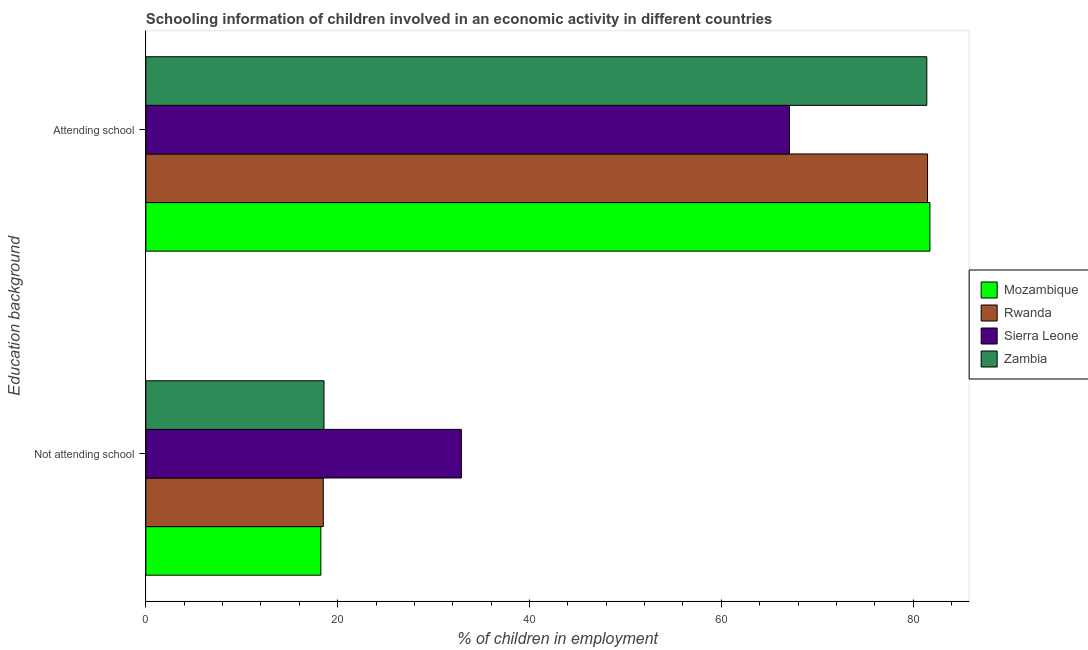Are the number of bars per tick equal to the number of legend labels?
Ensure brevity in your answer.  Yes. How many bars are there on the 2nd tick from the top?
Your answer should be very brief. 4. What is the label of the 1st group of bars from the top?
Keep it short and to the point. Attending school. What is the percentage of employed children who are attending school in Mozambique?
Provide a succinct answer. 81.75. Across all countries, what is the maximum percentage of employed children who are attending school?
Offer a very short reply. 81.75. Across all countries, what is the minimum percentage of employed children who are attending school?
Provide a succinct answer. 67.1. In which country was the percentage of employed children who are attending school maximum?
Provide a succinct answer. Mozambique. In which country was the percentage of employed children who are attending school minimum?
Ensure brevity in your answer.  Sierra Leone. What is the total percentage of employed children who are attending school in the graph?
Make the answer very short. 311.78. What is the difference between the percentage of employed children who are not attending school in Rwanda and that in Sierra Leone?
Your answer should be very brief. -14.4. What is the difference between the percentage of employed children who are attending school in Mozambique and the percentage of employed children who are not attending school in Rwanda?
Offer a very short reply. 63.25. What is the average percentage of employed children who are not attending school per country?
Keep it short and to the point. 22.06. What is the difference between the percentage of employed children who are not attending school and percentage of employed children who are attending school in Rwanda?
Provide a succinct answer. -63. In how many countries, is the percentage of employed children who are not attending school greater than 48 %?
Offer a terse response. 0. What is the ratio of the percentage of employed children who are not attending school in Sierra Leone to that in Rwanda?
Offer a terse response. 1.78. Is the percentage of employed children who are not attending school in Zambia less than that in Rwanda?
Your answer should be very brief. No. In how many countries, is the percentage of employed children who are not attending school greater than the average percentage of employed children who are not attending school taken over all countries?
Ensure brevity in your answer.  1. What does the 2nd bar from the top in Not attending school represents?
Offer a terse response. Sierra Leone. What does the 3rd bar from the bottom in Not attending school represents?
Provide a short and direct response. Sierra Leone. How many bars are there?
Keep it short and to the point. 8. How many countries are there in the graph?
Offer a terse response. 4. Does the graph contain any zero values?
Your response must be concise. No. Does the graph contain grids?
Offer a terse response. No. What is the title of the graph?
Provide a short and direct response. Schooling information of children involved in an economic activity in different countries. Does "Afghanistan" appear as one of the legend labels in the graph?
Keep it short and to the point. No. What is the label or title of the X-axis?
Your response must be concise. % of children in employment. What is the label or title of the Y-axis?
Provide a succinct answer. Education background. What is the % of children in employment in Mozambique in Not attending school?
Ensure brevity in your answer.  18.25. What is the % of children in employment of Sierra Leone in Not attending school?
Offer a terse response. 32.9. What is the % of children in employment of Zambia in Not attending school?
Ensure brevity in your answer.  18.58. What is the % of children in employment of Mozambique in Attending school?
Your response must be concise. 81.75. What is the % of children in employment of Rwanda in Attending school?
Provide a short and direct response. 81.5. What is the % of children in employment of Sierra Leone in Attending school?
Your response must be concise. 67.1. What is the % of children in employment of Zambia in Attending school?
Give a very brief answer. 81.42. Across all Education background, what is the maximum % of children in employment in Mozambique?
Provide a short and direct response. 81.75. Across all Education background, what is the maximum % of children in employment in Rwanda?
Offer a terse response. 81.5. Across all Education background, what is the maximum % of children in employment of Sierra Leone?
Your answer should be compact. 67.1. Across all Education background, what is the maximum % of children in employment of Zambia?
Give a very brief answer. 81.42. Across all Education background, what is the minimum % of children in employment in Mozambique?
Provide a succinct answer. 18.25. Across all Education background, what is the minimum % of children in employment of Sierra Leone?
Your response must be concise. 32.9. Across all Education background, what is the minimum % of children in employment in Zambia?
Your answer should be very brief. 18.58. What is the total % of children in employment of Mozambique in the graph?
Provide a short and direct response. 100. What is the total % of children in employment in Rwanda in the graph?
Offer a very short reply. 100. What is the total % of children in employment of Sierra Leone in the graph?
Provide a short and direct response. 100. What is the total % of children in employment in Zambia in the graph?
Make the answer very short. 100. What is the difference between the % of children in employment in Mozambique in Not attending school and that in Attending school?
Keep it short and to the point. -63.5. What is the difference between the % of children in employment in Rwanda in Not attending school and that in Attending school?
Ensure brevity in your answer.  -63. What is the difference between the % of children in employment of Sierra Leone in Not attending school and that in Attending school?
Keep it short and to the point. -34.2. What is the difference between the % of children in employment of Zambia in Not attending school and that in Attending school?
Your response must be concise. -62.85. What is the difference between the % of children in employment of Mozambique in Not attending school and the % of children in employment of Rwanda in Attending school?
Provide a short and direct response. -63.25. What is the difference between the % of children in employment in Mozambique in Not attending school and the % of children in employment in Sierra Leone in Attending school?
Keep it short and to the point. -48.85. What is the difference between the % of children in employment in Mozambique in Not attending school and the % of children in employment in Zambia in Attending school?
Keep it short and to the point. -63.18. What is the difference between the % of children in employment in Rwanda in Not attending school and the % of children in employment in Sierra Leone in Attending school?
Your answer should be compact. -48.6. What is the difference between the % of children in employment of Rwanda in Not attending school and the % of children in employment of Zambia in Attending school?
Make the answer very short. -62.92. What is the difference between the % of children in employment of Sierra Leone in Not attending school and the % of children in employment of Zambia in Attending school?
Offer a very short reply. -48.52. What is the average % of children in employment in Rwanda per Education background?
Provide a short and direct response. 50. What is the average % of children in employment in Sierra Leone per Education background?
Provide a short and direct response. 50. What is the average % of children in employment in Zambia per Education background?
Ensure brevity in your answer.  50. What is the difference between the % of children in employment in Mozambique and % of children in employment in Rwanda in Not attending school?
Offer a very short reply. -0.25. What is the difference between the % of children in employment of Mozambique and % of children in employment of Sierra Leone in Not attending school?
Provide a short and direct response. -14.65. What is the difference between the % of children in employment of Mozambique and % of children in employment of Zambia in Not attending school?
Offer a very short reply. -0.33. What is the difference between the % of children in employment in Rwanda and % of children in employment in Sierra Leone in Not attending school?
Offer a very short reply. -14.4. What is the difference between the % of children in employment in Rwanda and % of children in employment in Zambia in Not attending school?
Your answer should be very brief. -0.08. What is the difference between the % of children in employment in Sierra Leone and % of children in employment in Zambia in Not attending school?
Give a very brief answer. 14.32. What is the difference between the % of children in employment of Mozambique and % of children in employment of Rwanda in Attending school?
Ensure brevity in your answer.  0.25. What is the difference between the % of children in employment in Mozambique and % of children in employment in Sierra Leone in Attending school?
Offer a very short reply. 14.65. What is the difference between the % of children in employment of Mozambique and % of children in employment of Zambia in Attending school?
Provide a succinct answer. 0.33. What is the difference between the % of children in employment of Rwanda and % of children in employment of Zambia in Attending school?
Ensure brevity in your answer.  0.08. What is the difference between the % of children in employment in Sierra Leone and % of children in employment in Zambia in Attending school?
Ensure brevity in your answer.  -14.32. What is the ratio of the % of children in employment in Mozambique in Not attending school to that in Attending school?
Provide a short and direct response. 0.22. What is the ratio of the % of children in employment of Rwanda in Not attending school to that in Attending school?
Give a very brief answer. 0.23. What is the ratio of the % of children in employment of Sierra Leone in Not attending school to that in Attending school?
Make the answer very short. 0.49. What is the ratio of the % of children in employment in Zambia in Not attending school to that in Attending school?
Make the answer very short. 0.23. What is the difference between the highest and the second highest % of children in employment of Mozambique?
Offer a terse response. 63.5. What is the difference between the highest and the second highest % of children in employment in Rwanda?
Provide a succinct answer. 63. What is the difference between the highest and the second highest % of children in employment of Sierra Leone?
Ensure brevity in your answer.  34.2. What is the difference between the highest and the second highest % of children in employment of Zambia?
Keep it short and to the point. 62.85. What is the difference between the highest and the lowest % of children in employment in Mozambique?
Offer a very short reply. 63.5. What is the difference between the highest and the lowest % of children in employment in Sierra Leone?
Provide a short and direct response. 34.2. What is the difference between the highest and the lowest % of children in employment in Zambia?
Your response must be concise. 62.85. 